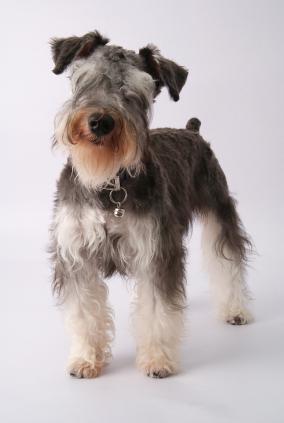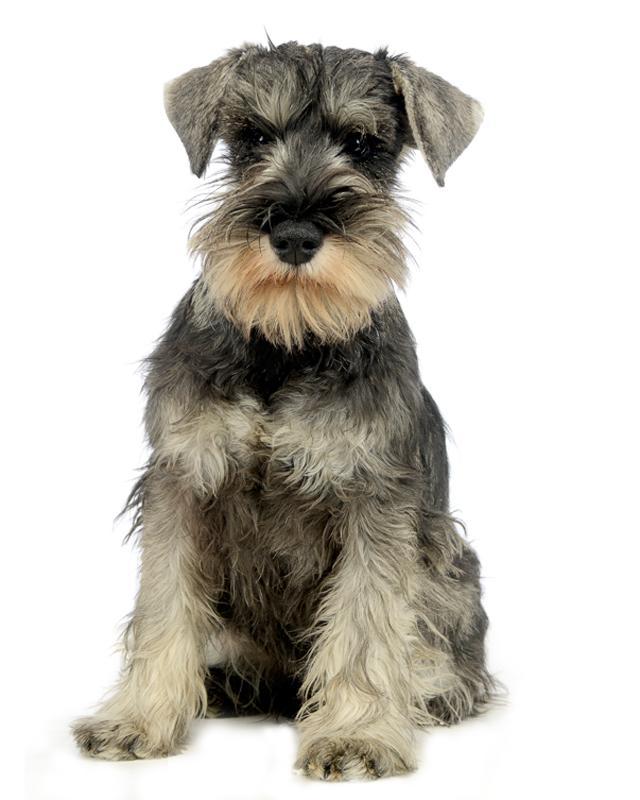The first image is the image on the left, the second image is the image on the right. For the images displayed, is the sentence "One of the images shows a dog that is standing." factually correct? Answer yes or no. Yes. 